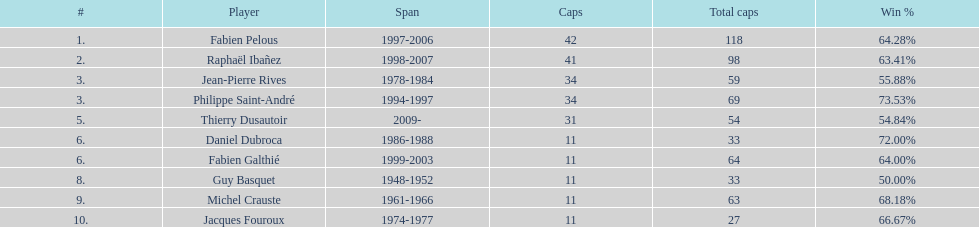How many caps did guy basquet accrue during his career? 33. 